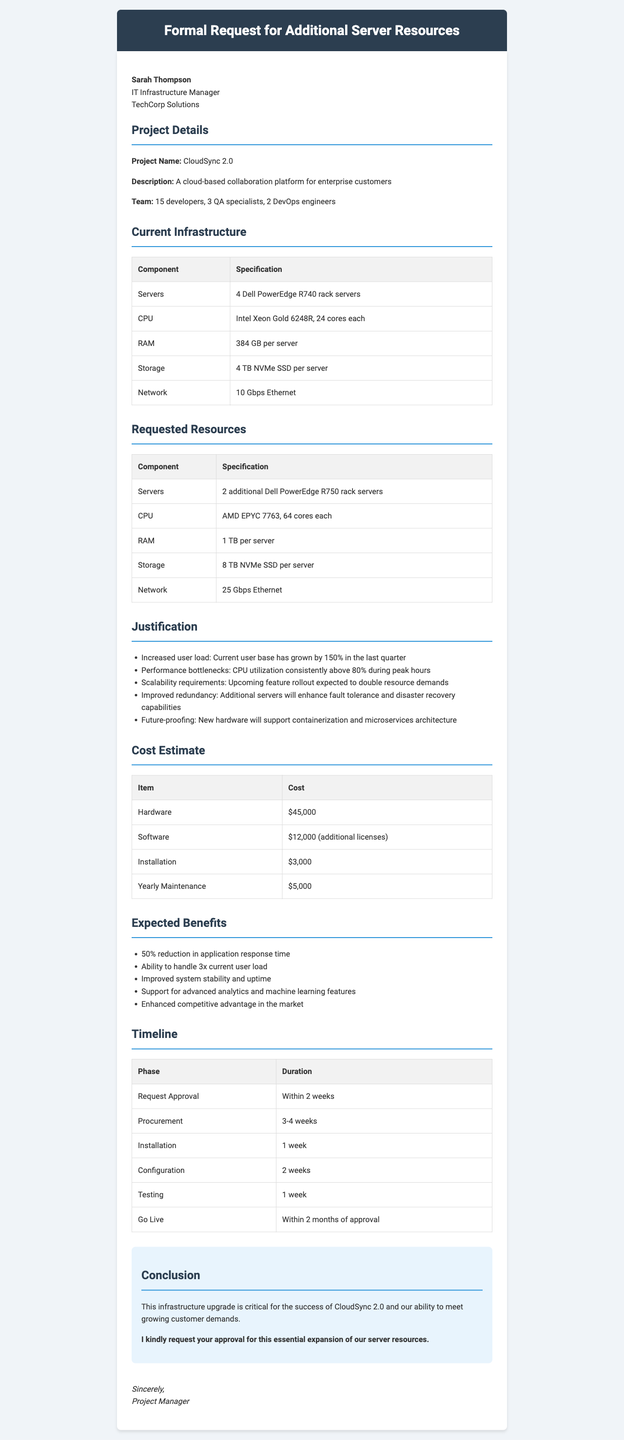What is the title of the letter? The title is the main heading of the letter addressing the request made to the recipient.
Answer: Formal Request for Additional Server Resources Who is the recipient of the letter? The recipient's name and title are listed in the letter's header.
Answer: Sarah Thompson How many developers are on the project team? The number of developers is specified in the project details section.
Answer: 15 developers What is the current storage capacity per server? The current infrastructure section states the storage capacity per server.
Answer: 4 TB NVMe SSD per server What CPU is included in the requested resources? The requested resources section specifies the CPU model for the new servers.
Answer: AMD EPYC 7763 What is the estimated cost for hardware? The cost estimate section provides the hardware cost specifically.
Answer: $45,000 What percentage reduction in application response time is expected? The expected benefits section states the anticipated improvement in response time.
Answer: 50% reduction What is the approval request timeline? The timeline section indicates how quickly approval is requested for the letter.
Answer: Within 2 weeks What is the purpose of the letter? The letter formally requests additional server resources for meeting project demands in the conclusion.
Answer: Request for additional server resources 